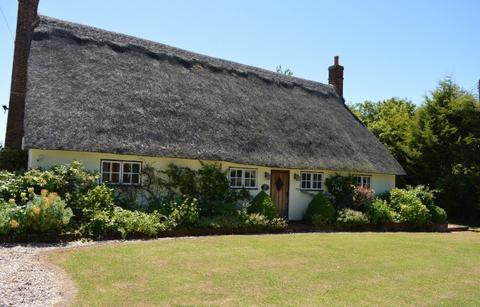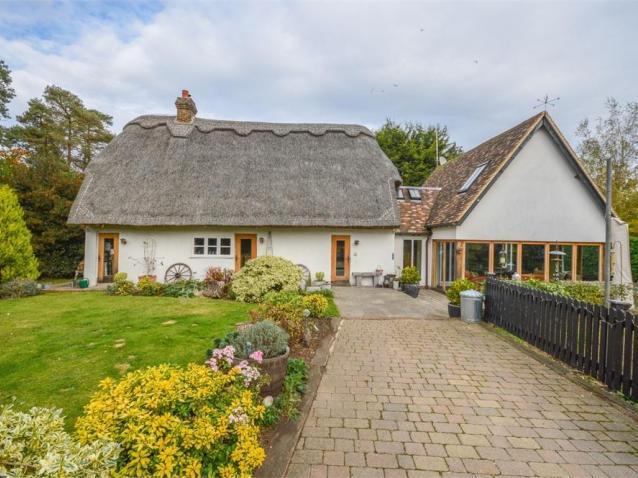The first image is the image on the left, the second image is the image on the right. For the images shown, is this caption "All the houses have chimneys." true? Answer yes or no. Yes. 